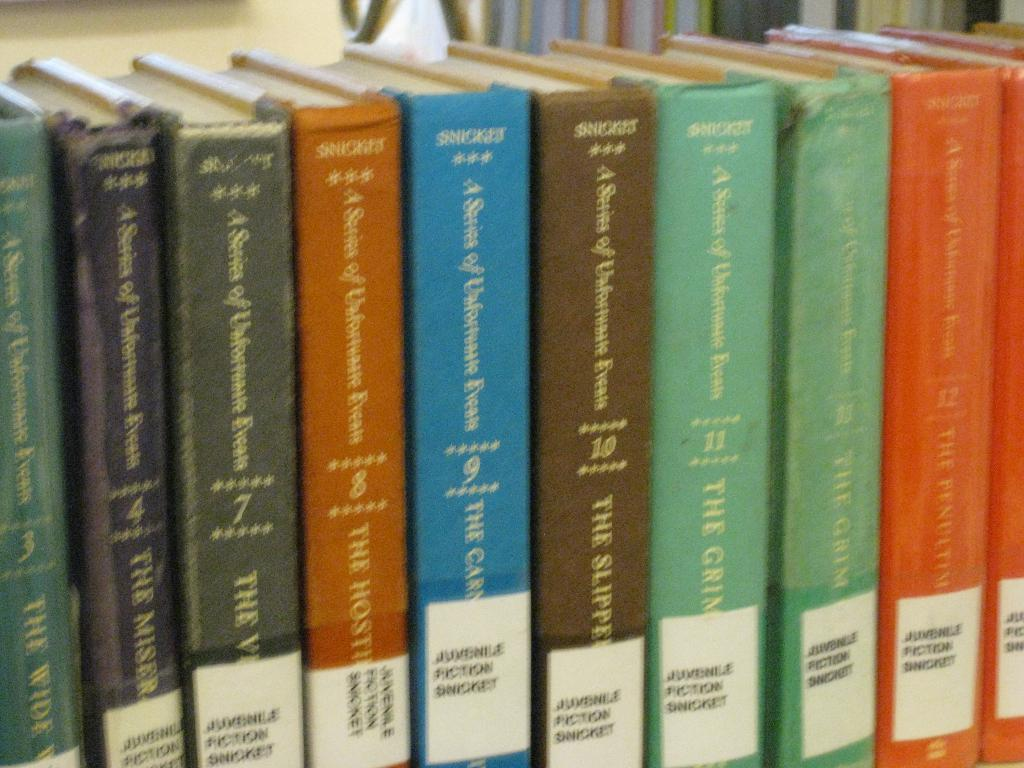What objects can be seen in the image? There are books in the image. How are the books arranged? The books are arranged in the image. What type of jeans are being worn by the tomatoes in the image? There are no tomatoes or jeans present in the image; it only features books. 